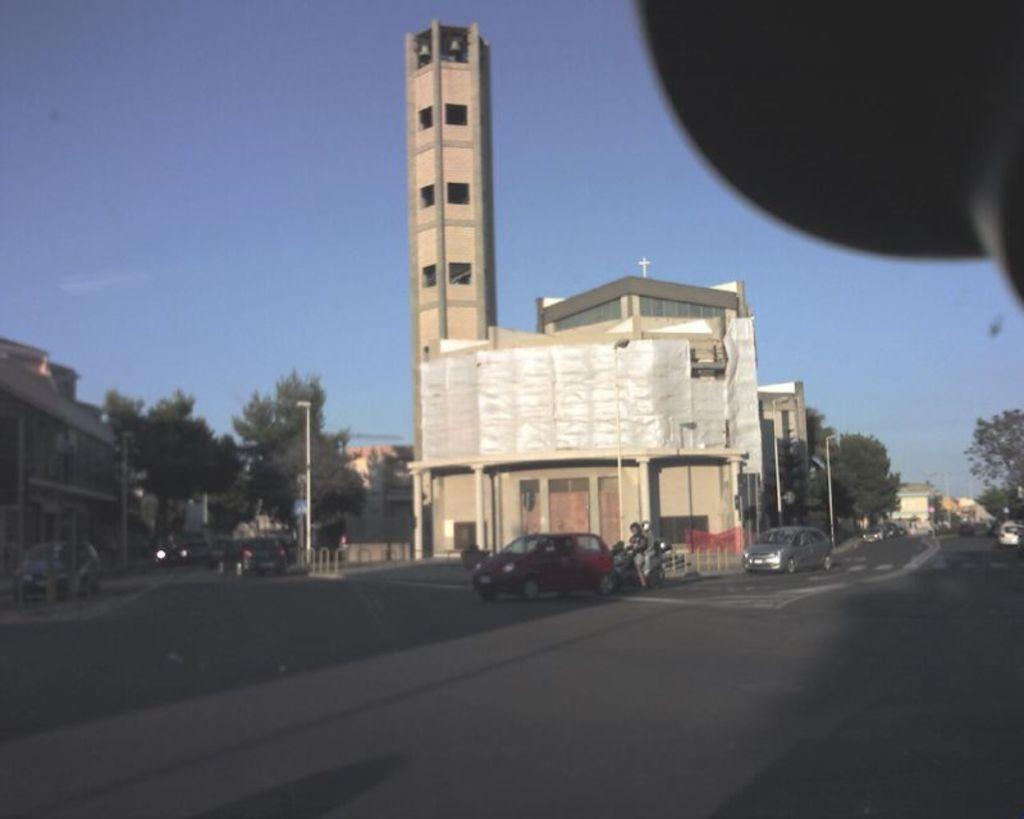Could you give a brief overview of what you see in this image? In the picture there is a tall tower beside a church and many vehicles are moving on the road in front of the church, on the left side there are few trees. 